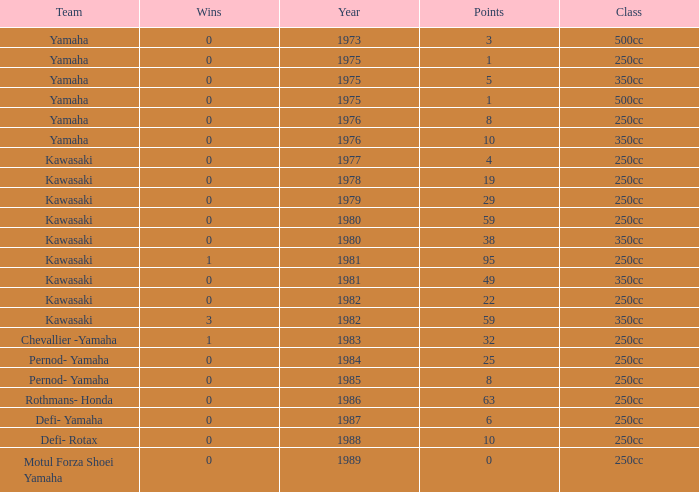How many points numbers had a class of 250cc, a year prior to 1978, Yamaha as a team, and where wins was more than 0? 0.0. 